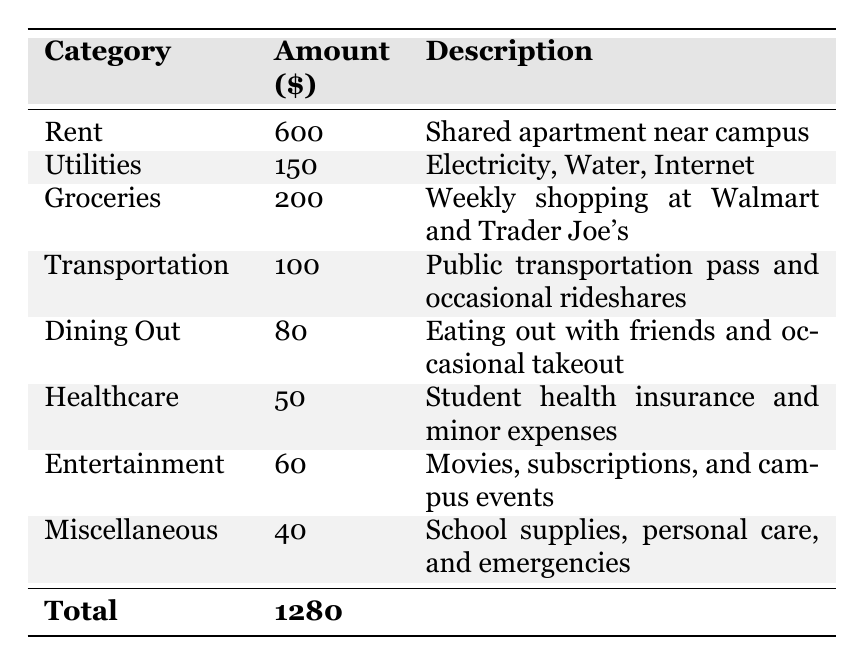What is the total amount allocated for transportation? The table lists transportation expenses under the category "Transportation" with an amount of $100. Therefore, the total allocated for transportation is simply the value given in that row.
Answer: 100 How much more does the student spend on groceries than on dining out? Groceries cost $200 and dining out costs $80. To find the difference, subtract the dining out amount from the groceries amount: $200 - $80 = $120.
Answer: 120 What is the total amount spent on healthcare and entertainment combined? The healthcare amount is $50, and the entertainment amount is $60. To find the total, add these two amounts together: $50 + $60 = $110.
Answer: 110 Is the amount spent on utilities higher than the amount spent on transportation? Utilities cost $150 while transportation costs $100. Since $150 is greater than $100, the statement is true.
Answer: Yes What percentage of the total budget is allocated to rent? The total budget is $1280, and rent is $600. To find the percentage, divide the rent by the total and multiply by 100: ($600 / $1280) * 100 ≈ 46.88%.
Answer: Approximately 46.88% If the student decided to cut entertainment expenses in half, how much would the remaining budget for entertainment be? The original entertainment expense is $60. Cutting it in half means dividing by 2: $60 / 2 = $30.
Answer: 30 What is the total amount spent on dining out and miscellaneous expenses together? Dining out costs $80 and miscellaneous expenses cost $40. To find the total amount, add these two figures: $80 + $40 = $120.
Answer: 120 If the student wanted to stay within a budget of $1000, how much could they reduce their total expenses by? The total expenses are $1280. To find out how much they need to cut to stay within a $1000 budget: $1280 - $1000 = $280.
Answer: 280 Which category has the lowest expenditure, and what is the amount? The miscellaneous category is listed at $40, which is lower than any other category in the table.
Answer: Miscellaneous: 40 How much do utilities and transportation expenses add up to? Utilities amount to $150 and transportation amounts to $100. Adding these amounts gives: $150 + $100 = $250.
Answer: 250 